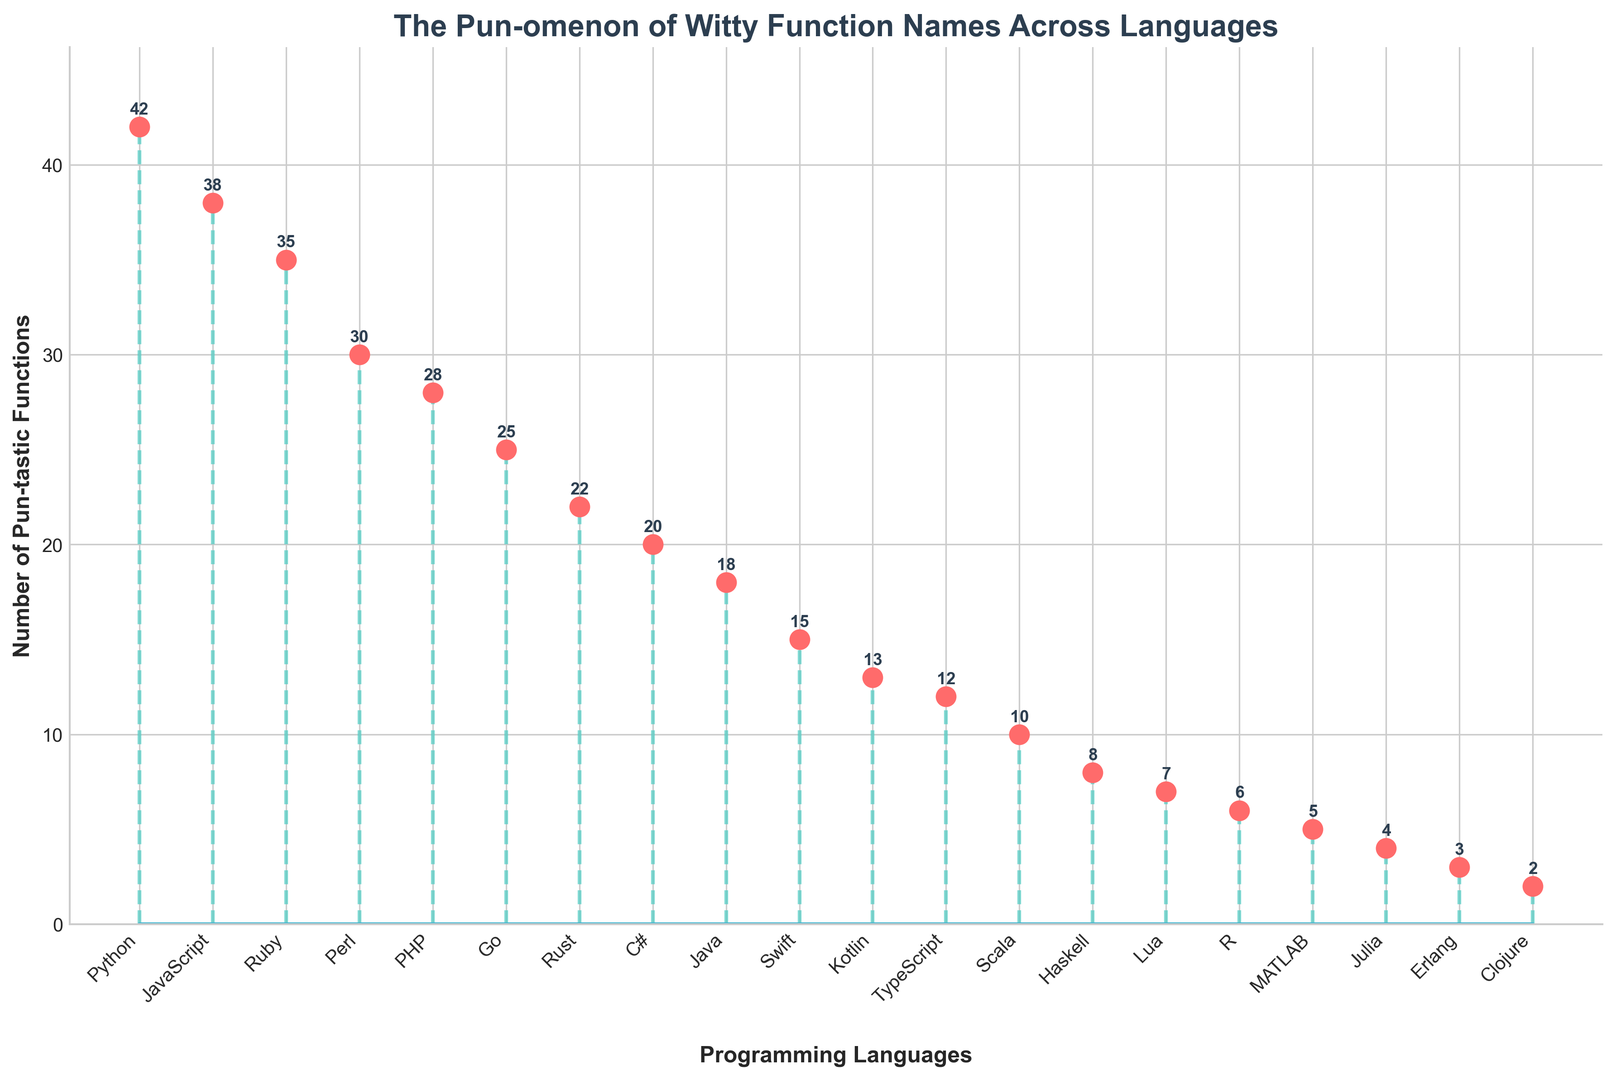How many total programming languages are shown in the plot? Count the number of unique programming languages listed along the x-axis.
Answer: 19 Which programming language has the highest count of pun-based function names? Identify the vertical stem that reaches the highest point in the plot.
Answer: Python What is the difference in pun function counts between Python and Ruby? Subtract the count of Ruby from the count of Python (42 - 35).
Answer: 7 Which language has fewer pun-based function names, Rust or Go? Compare the heights of the stems for Rust and Go.
Answer: Rust What is the combined count of pun-based function names for Python, JavaScript, and Ruby? Add the counts for Python, JavaScript, and Ruby (42 + 38 + 35).
Answer: 115 Which language has the shortest stem? Identify the stem that has the lowest height.
Answer: Clojure Are there more pun-based function names in Swift or Kotlin? Compare the stem heights between Swift and Kotlin.
Answer: Swift What's the percentage difference in pun function counts between Java and C#? Calculate the difference between Java and C# (20 - 18), then divide by the count for C# (2 / 20) and multiply by 100.
Answer: 10% If the number of pun-based functions in Haskell doubled, would it surpass Python's count? Double Haskell's count (8 * 2 = 16) and compare to Python's 42.
Answer: No Which two languages have exactly 5 and 7 pun-based function counts? Identify the languages corresponding to these stem heights.
Answer: MATLAB and Lua 